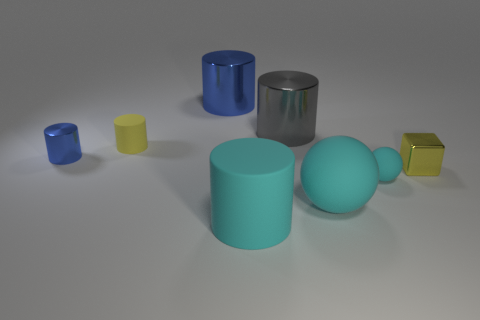Is there a purple sphere that has the same material as the yellow cylinder?
Make the answer very short. No. There is a cyan matte sphere that is behind the large object to the right of the large gray metal cylinder; is there a large blue shiny object behind it?
Offer a terse response. Yes. There is a big cyan rubber cylinder; are there any large blue shiny cylinders behind it?
Your answer should be very brief. Yes. Are there any small objects that have the same color as the tiny metal cube?
Keep it short and to the point. Yes. How many large things are yellow metal blocks or rubber things?
Your answer should be compact. 2. Is the material of the small yellow thing left of the big blue object the same as the large sphere?
Offer a terse response. Yes. What is the shape of the big cyan rubber object behind the large rubber object left of the large gray shiny cylinder behind the metal block?
Your response must be concise. Sphere. How many cyan things are either small matte cylinders or tiny objects?
Give a very brief answer. 1. Are there the same number of spheres that are on the left side of the big ball and large blue cylinders that are to the left of the tiny cyan matte object?
Ensure brevity in your answer.  No. Do the small matte thing that is left of the big gray metal cylinder and the metal object on the right side of the big gray object have the same shape?
Your answer should be compact. No. 